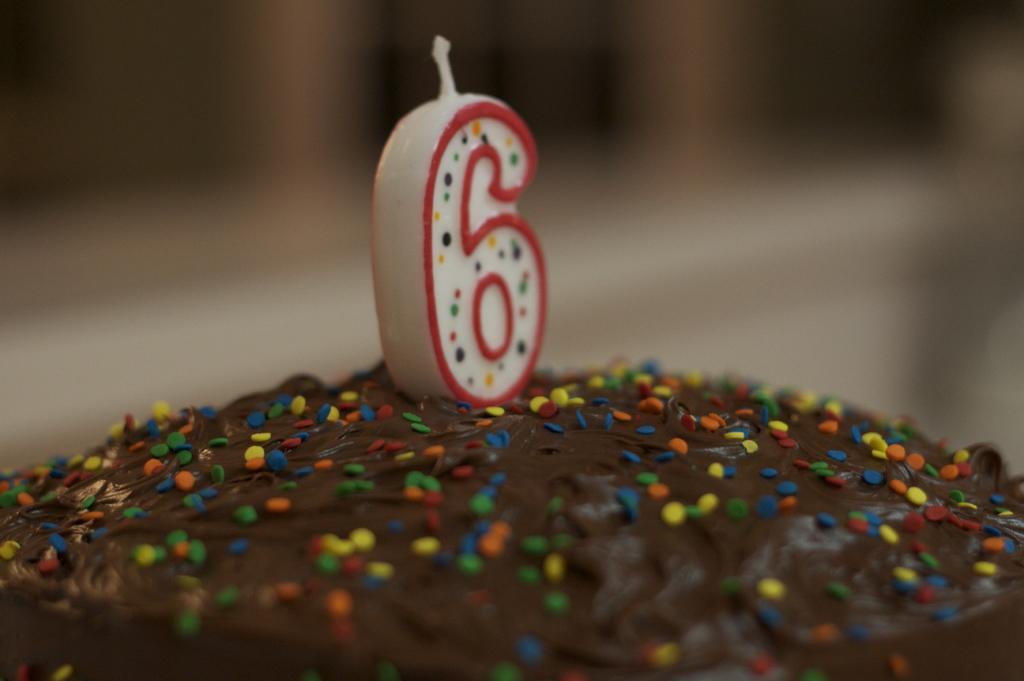Describe this image in one or two sentences. In the picture I can see the cake and there is a number candle on the cake. 